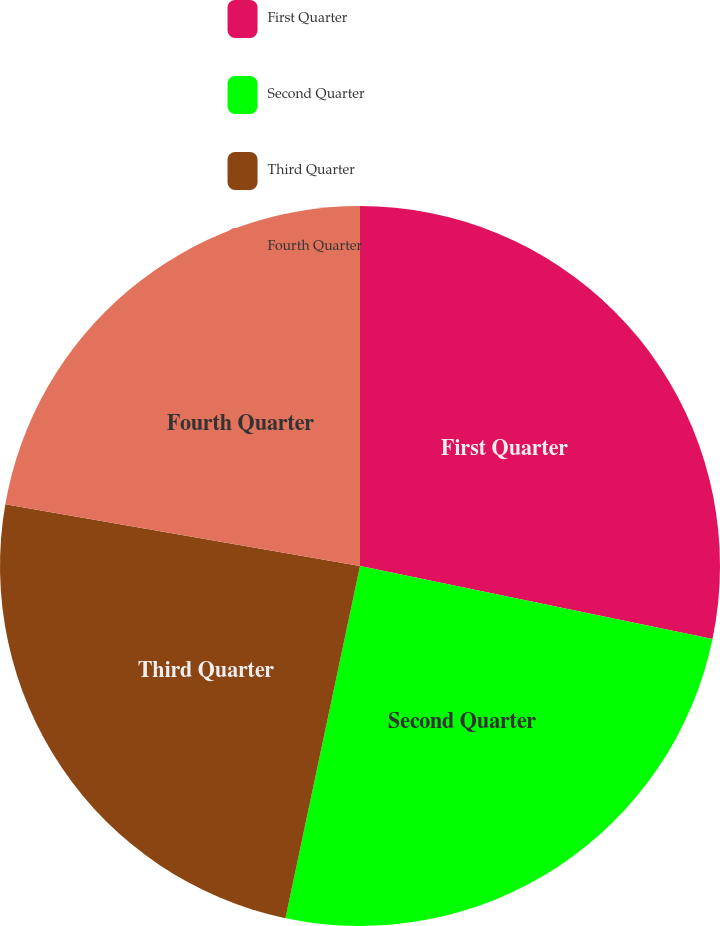Convert chart to OTSL. <chart><loc_0><loc_0><loc_500><loc_500><pie_chart><fcel>First Quarter<fcel>Second Quarter<fcel>Third Quarter<fcel>Fourth Quarter<nl><fcel>28.25%<fcel>25.07%<fcel>24.42%<fcel>22.26%<nl></chart> 